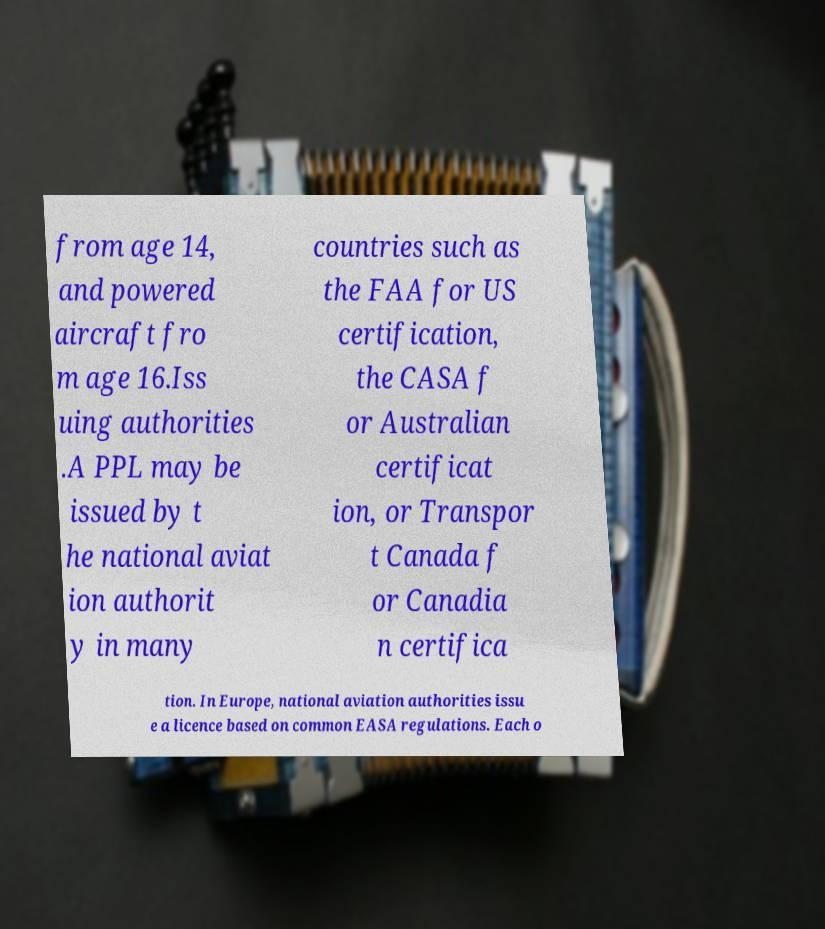Can you read and provide the text displayed in the image?This photo seems to have some interesting text. Can you extract and type it out for me? from age 14, and powered aircraft fro m age 16.Iss uing authorities .A PPL may be issued by t he national aviat ion authorit y in many countries such as the FAA for US certification, the CASA f or Australian certificat ion, or Transpor t Canada f or Canadia n certifica tion. In Europe, national aviation authorities issu e a licence based on common EASA regulations. Each o 